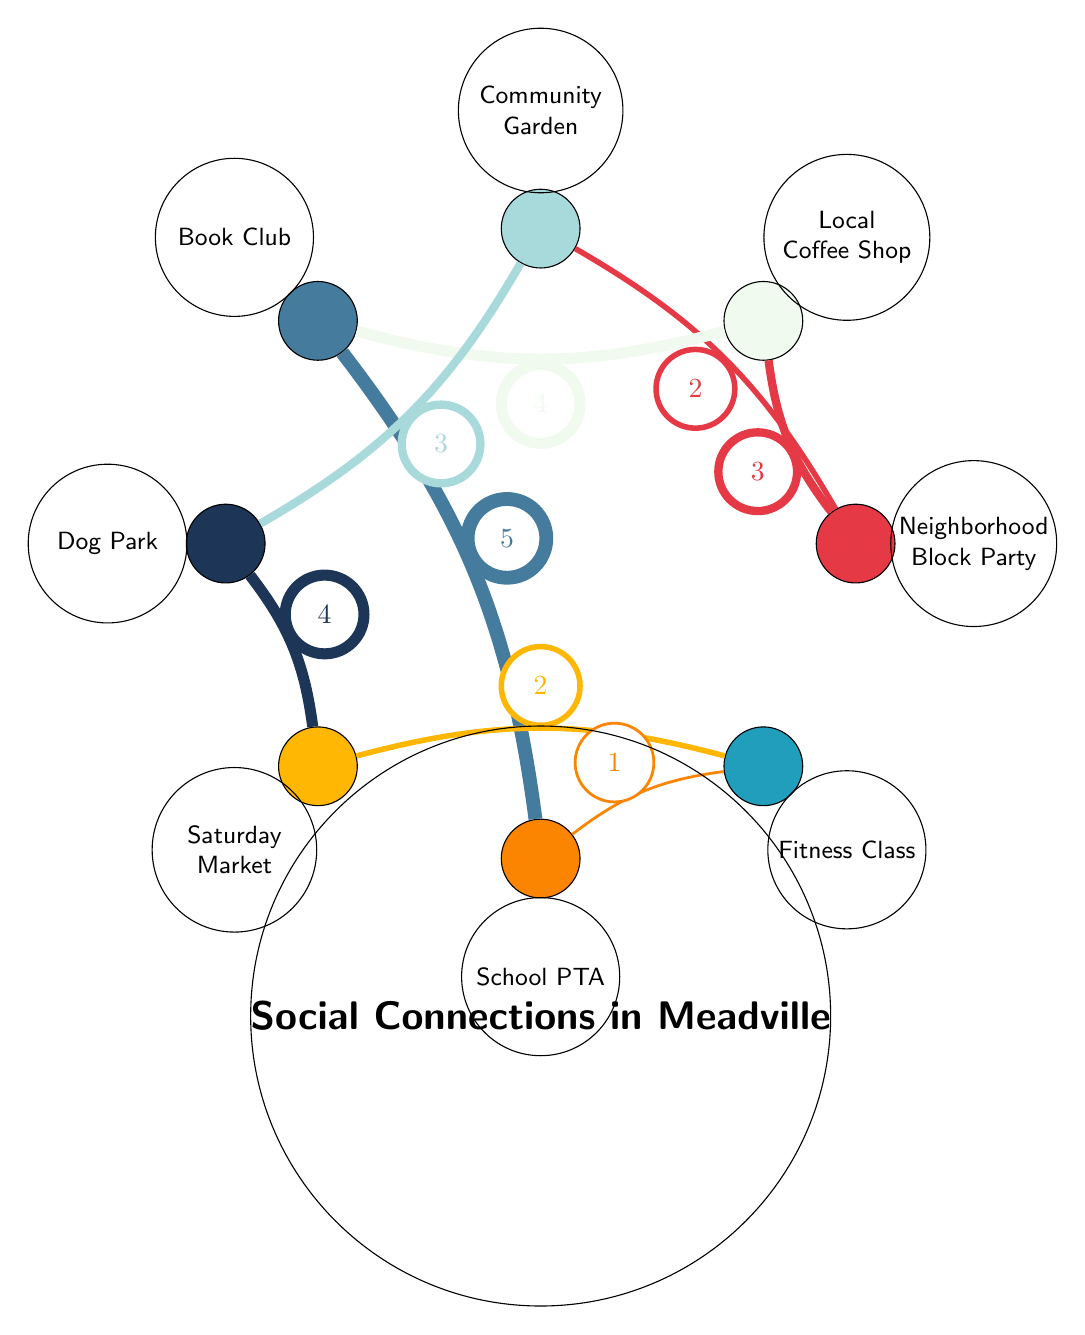What is the value between Neighborhood Block Party and Local Coffee Shop? The diagram shows a direct connection (edge) between Neighborhood Block Party and Local Coffee Shop, with an associated value of 3.
Answer: 3 Which two activities are connected to the Community Garden? The Community Garden has direct connections to Dog Park (value 3) and Neighborhood Block Party (value 2).
Answer: Dog Park, Neighborhood Block Party What is the maximum value connection in this diagram? The connection with the highest value is between Book Club and School PTA, which has a value of 5.
Answer: 5 How many nodes are in this diagram? By counting the listed nodes in the diagram, there are a total of 8 nodes present.
Answer: 8 Which node connects to the Fitness Class with the least value? The connection with the least value to Fitness Class is from School PTA, with a value of 1.
Answer: School PTA Which activity has the highest number of connections? The Book Club connects to three different activities: Local Coffee Shop, School PTA, and it connects through the Community Garden, making it the most connected node.
Answer: Book Club What is the value of the connection from Dog Park to Saturday Market? A direct connection exists between Dog Park and Saturday Market, with associated value indicated as 4.
Answer: 4 How many connections does the Local Coffee Shop have? The Local Coffee Shop connects to two activities: Neighborhood Block Party and Book Club, totaling two connections.
Answer: 2 